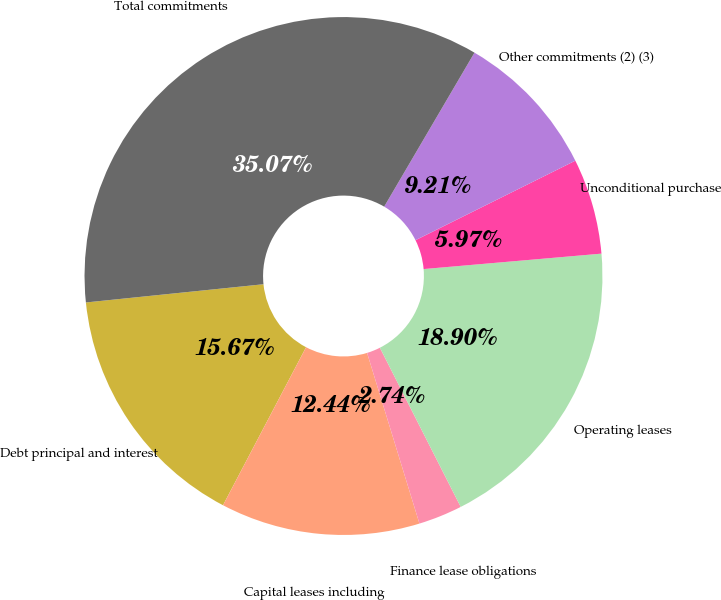<chart> <loc_0><loc_0><loc_500><loc_500><pie_chart><fcel>Debt principal and interest<fcel>Capital leases including<fcel>Finance lease obligations<fcel>Operating leases<fcel>Unconditional purchase<fcel>Other commitments (2) (3)<fcel>Total commitments<nl><fcel>15.67%<fcel>12.44%<fcel>2.74%<fcel>18.9%<fcel>5.97%<fcel>9.21%<fcel>35.07%<nl></chart> 